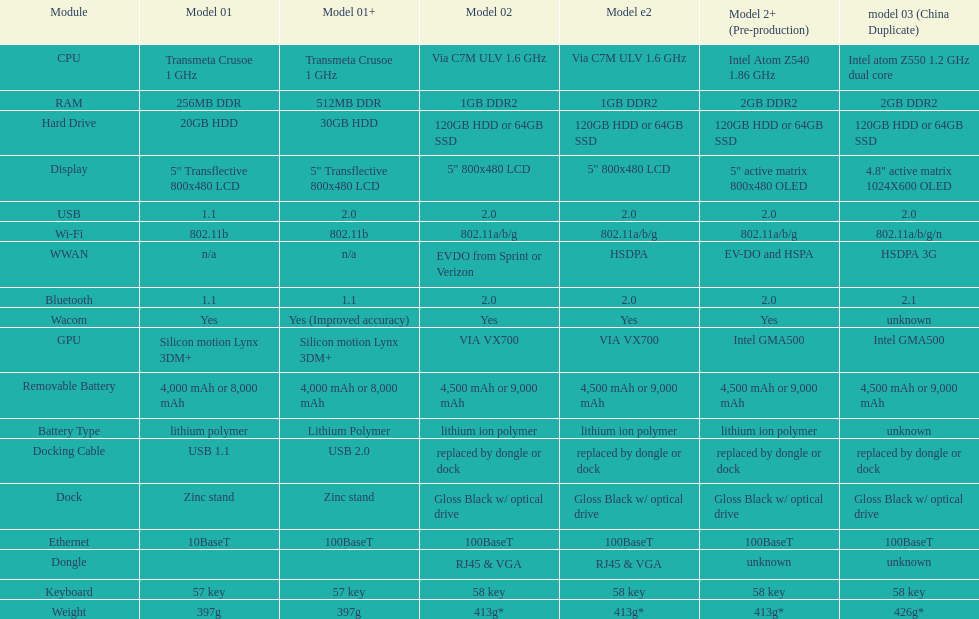What is the total number of components on the chart? 18. 